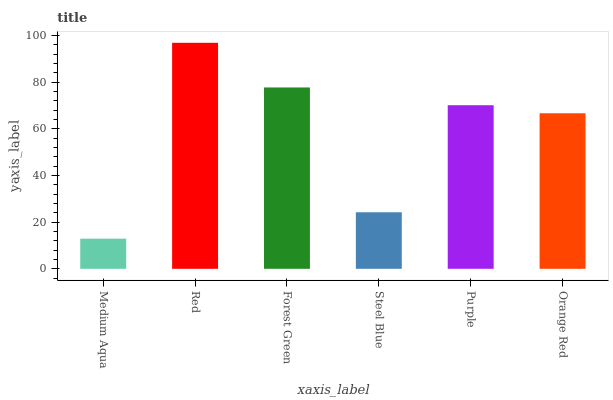Is Forest Green the minimum?
Answer yes or no. No. Is Forest Green the maximum?
Answer yes or no. No. Is Red greater than Forest Green?
Answer yes or no. Yes. Is Forest Green less than Red?
Answer yes or no. Yes. Is Forest Green greater than Red?
Answer yes or no. No. Is Red less than Forest Green?
Answer yes or no. No. Is Purple the high median?
Answer yes or no. Yes. Is Orange Red the low median?
Answer yes or no. Yes. Is Red the high median?
Answer yes or no. No. Is Purple the low median?
Answer yes or no. No. 